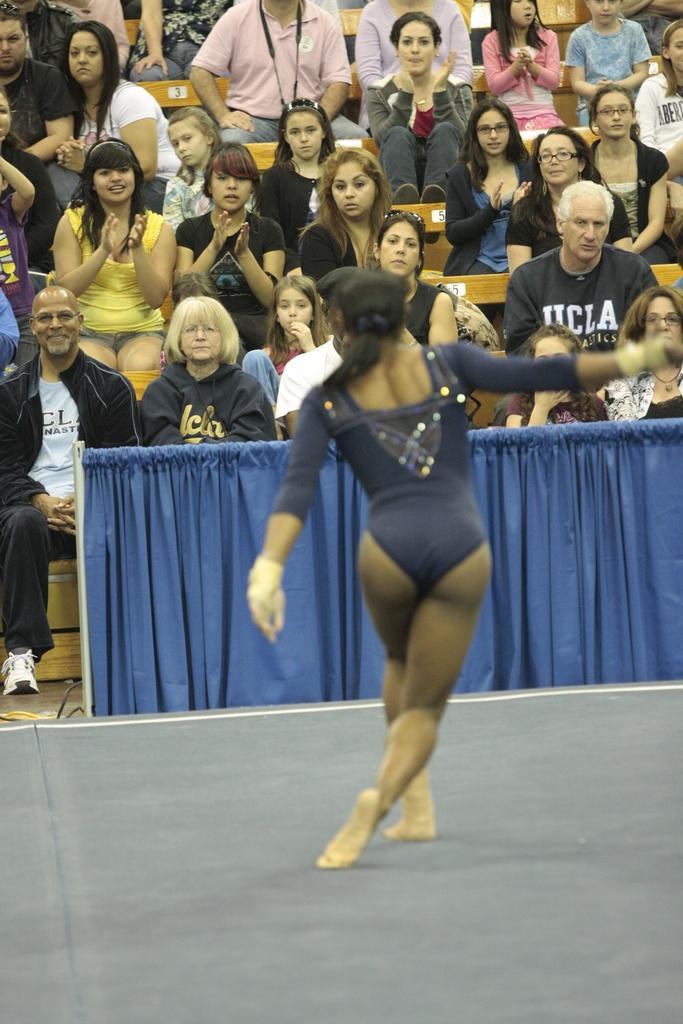Could you give a brief overview of what you see in this image? In the center of the image we can see a lady and there is a curtain. In the background we can see the crowd sitting. 